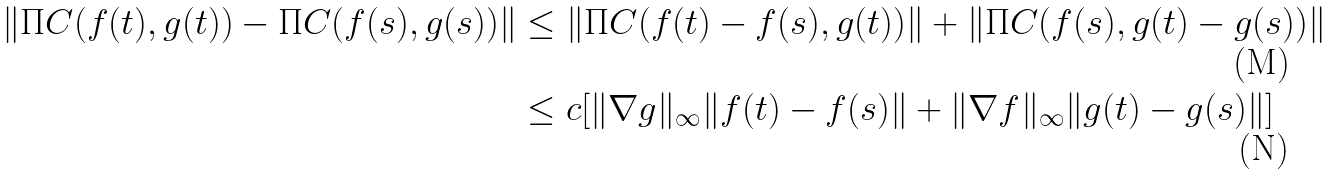Convert formula to latex. <formula><loc_0><loc_0><loc_500><loc_500>\| \Pi C ( f ( t ) , g ( t ) ) - \Pi C ( f ( s ) , g ( s ) ) \| & \leq \| \Pi C ( f ( t ) - f ( s ) , g ( t ) ) \| + \| \Pi C ( f ( s ) , g ( t ) - g ( s ) ) \| \\ & \leq c [ \| \nabla g \| _ { \infty } \| f ( t ) - f ( s ) \| + \| \nabla f \| _ { \infty } \| g ( t ) - g ( s ) \| ]</formula> 